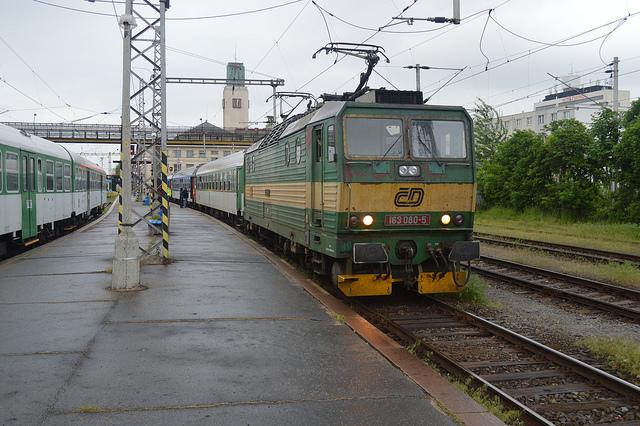What number is on the train?
Short answer required. 163-000-5. What color is the bridge?
Concise answer only. White. What color is the stripe around the green train?
Write a very short answer. Yellow. What color is the train?
Write a very short answer. Green and yellow. What colors are the train?
Keep it brief. Yellow and green. What color is the tall peak, in the background?
Give a very brief answer. Green. What powers the train on the right?
Concise answer only. Electricity. What color are the lights on the train?
Quick response, please. Yellow. 